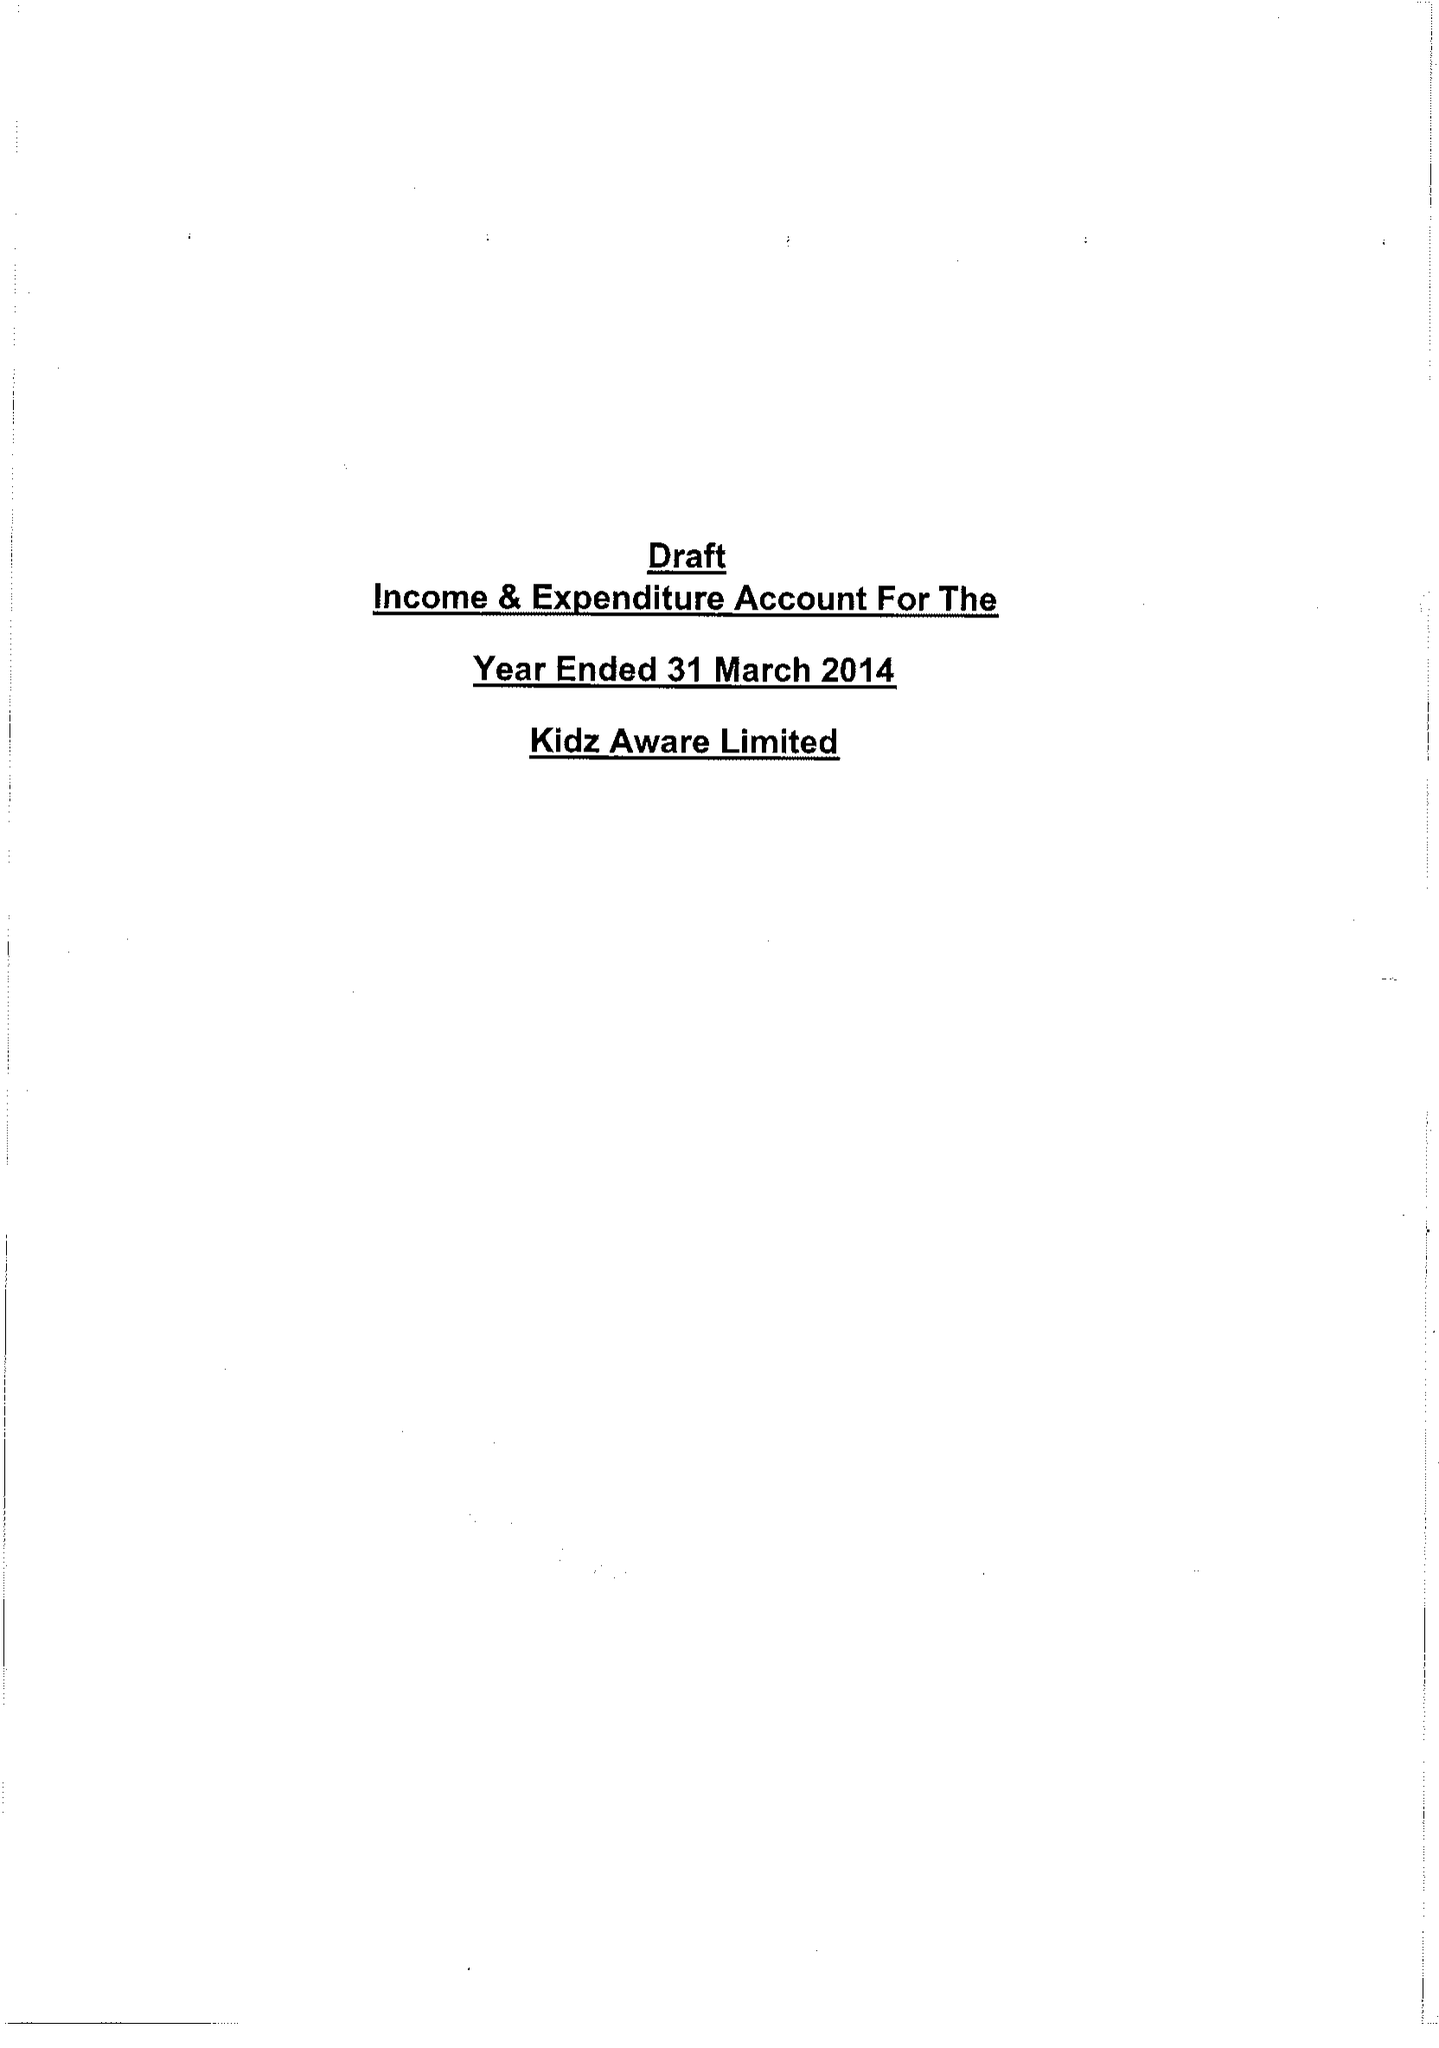What is the value for the income_annually_in_british_pounds?
Answer the question using a single word or phrase. 54567.00 